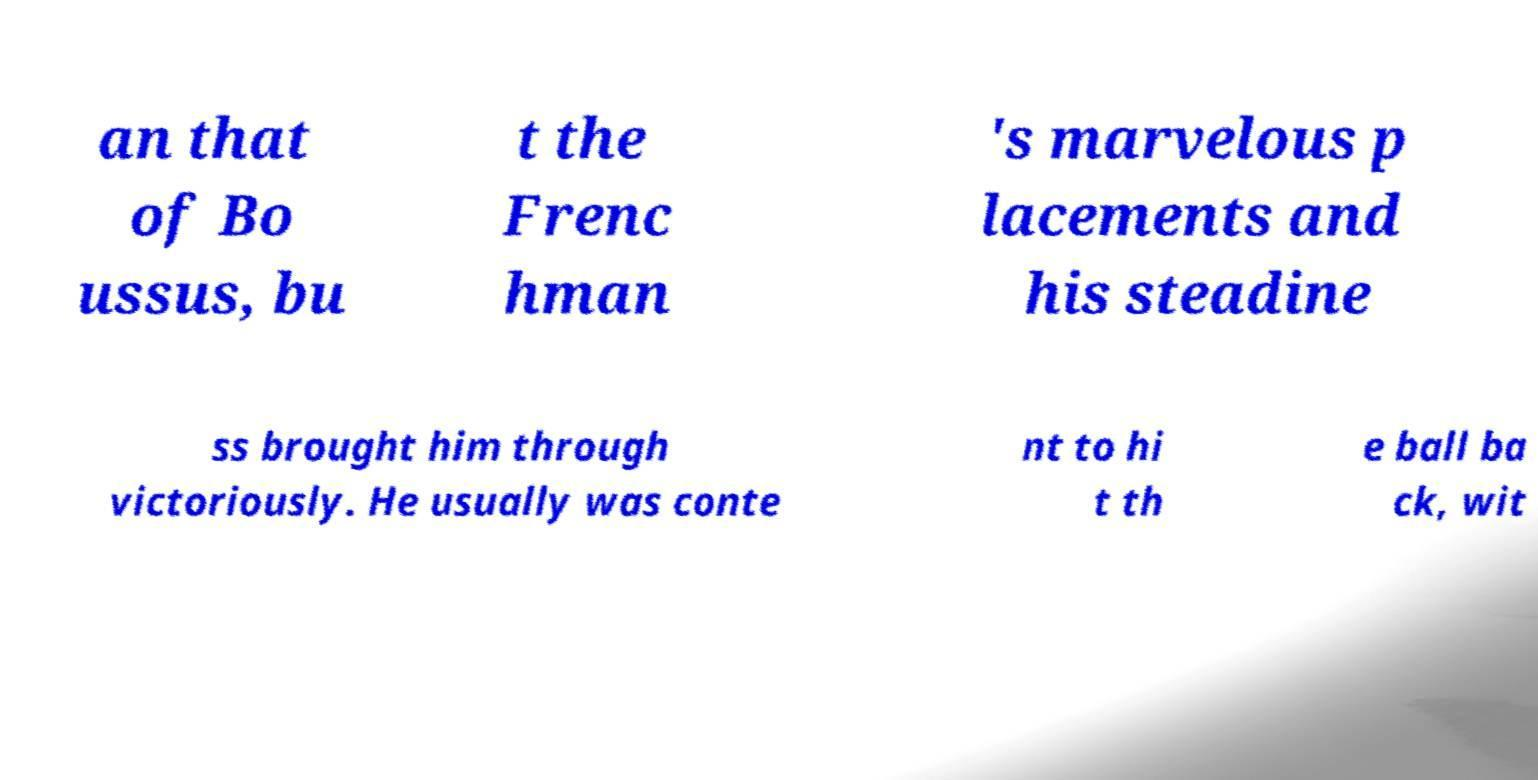There's text embedded in this image that I need extracted. Can you transcribe it verbatim? an that of Bo ussus, bu t the Frenc hman 's marvelous p lacements and his steadine ss brought him through victoriously. He usually was conte nt to hi t th e ball ba ck, wit 